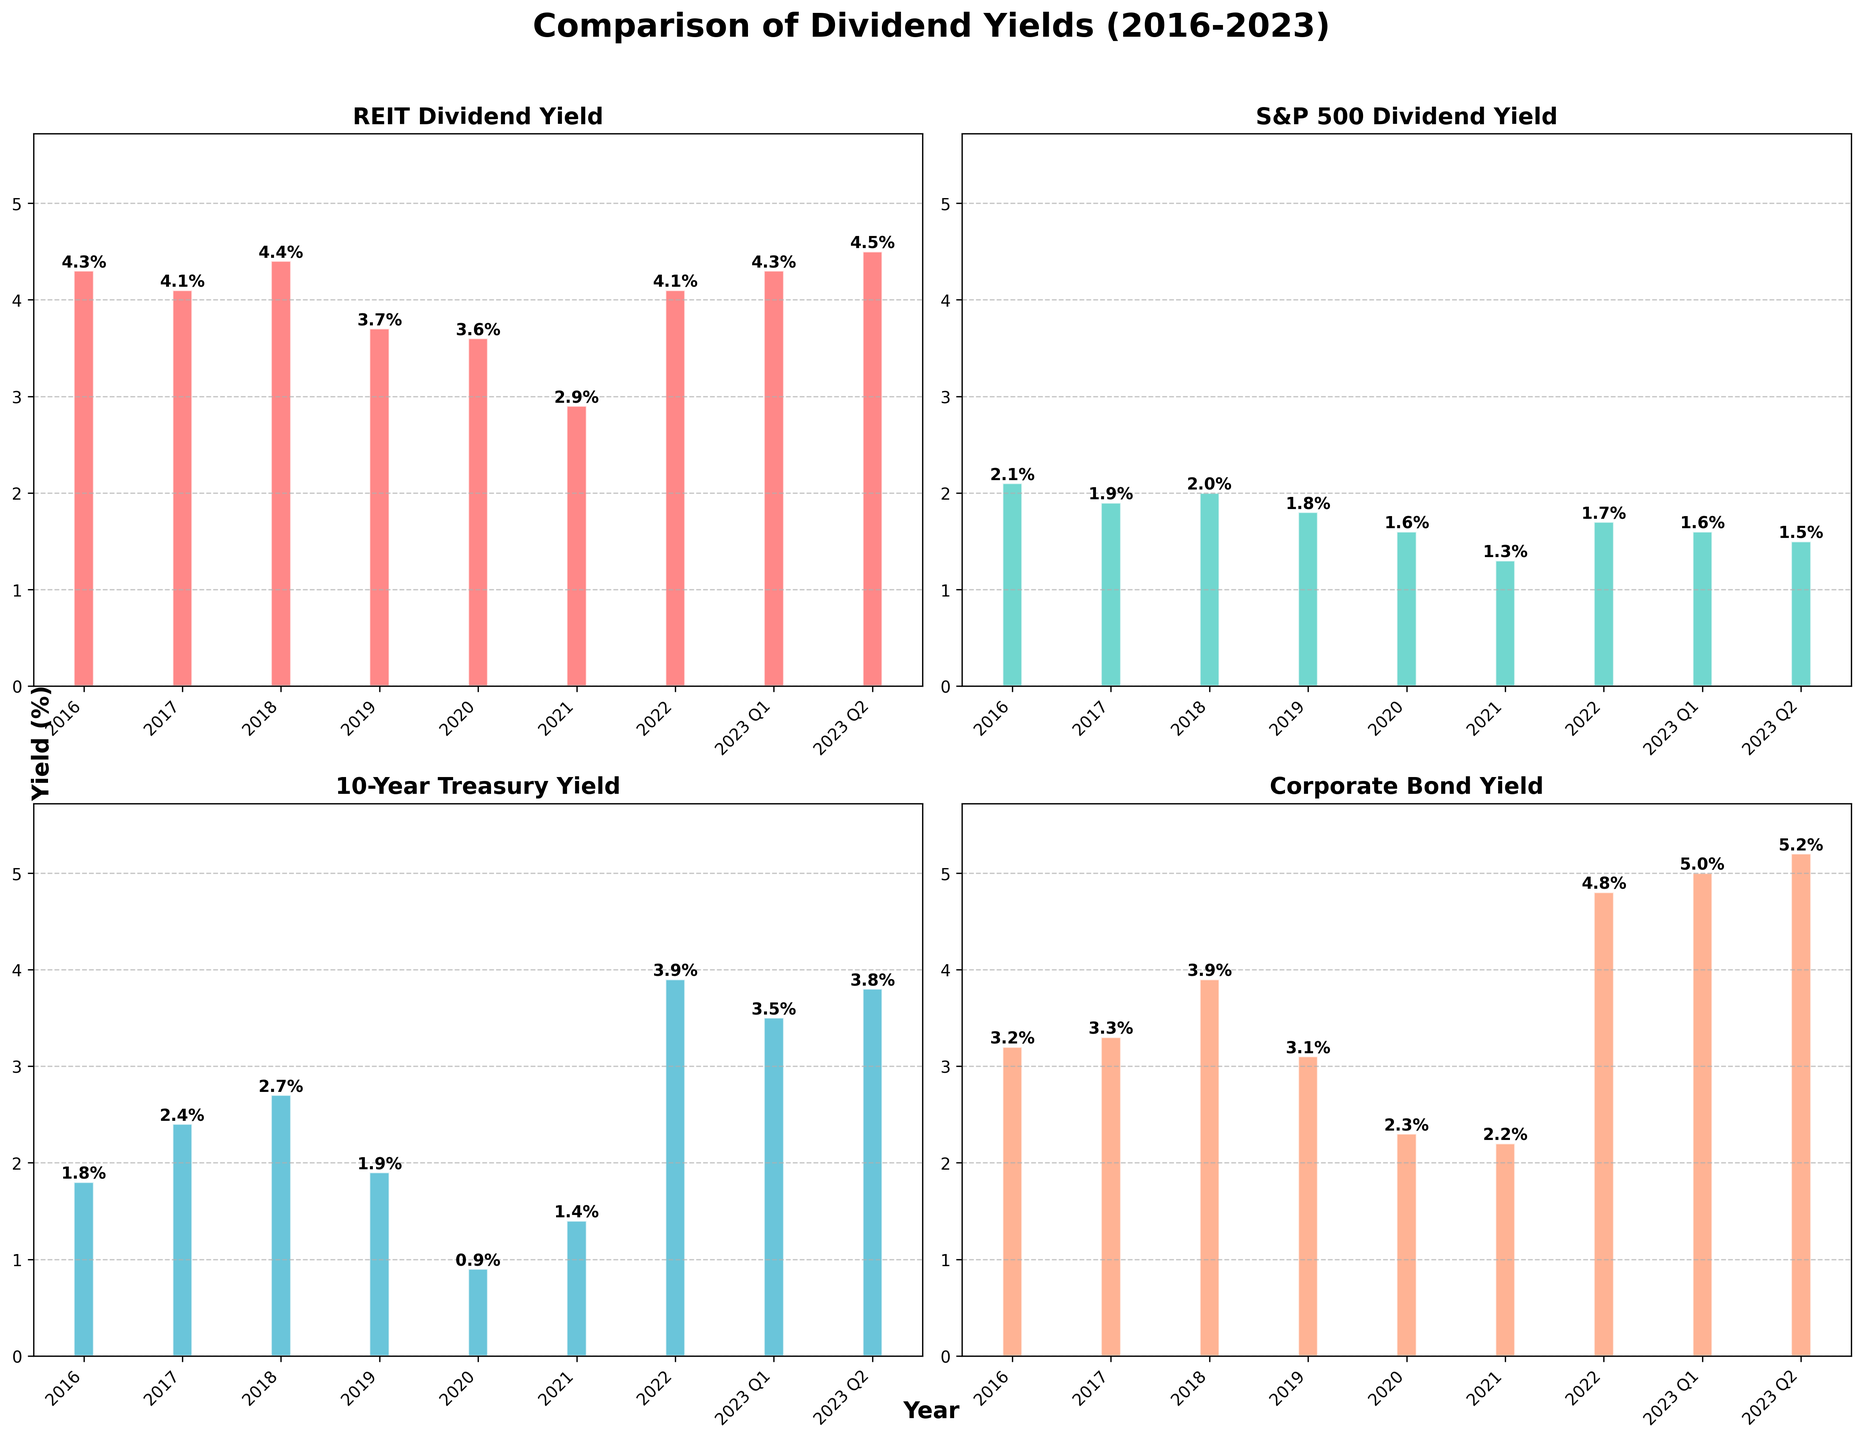Which investment type had the highest dividend yield in 2022? By looking at the bars for 2022 in each subplot, we see that the Corporate Bond Yield bar is the tallest.
Answer: Corporate Bond Yield How did the REIT dividend yield change from 2020 to 2021? To determine this, we look at the heights of the bars in the REIT Dividend Yield subplot for the years 2020 and 2021. The yield decreased from 3.6% in 2020 to 2.9% in 2021.
Answer: Decreased by 0.7% Is the S&P 500 dividend yield in 2023 Q2 higher or lower than in 2016? By comparing the bar heights for the years 2016 and 2023 Q2 in the S&P 500 Dividend Yield subplot, the yield decreased from 2.1% in 2016 to 1.5% in 2023 Q2.
Answer: Lower Which year had the lowest 10-Year Treasury Yield and what was that yield? By identifying the shortest bar in the 10-Year Treasury Yield subplot, we see that the year 2020 had the lowest yield at 0.9%.
Answer: 2020, 0.9% In which year(s) were the Corporate Bond yields higher than the REIT dividend yields? Compare the heights of the bars for Corporate Bond Yields and REIT Dividend Yields for each year. Corporate Bond Yields were higher in 2018, 2022, 2023 Q1, and 2023 Q2.
Answer: 2018, 2022, 2023 Q1, 2023 Q2 What is the average 10-Year Treasury Yield from 2016 to 2022? Sum the 10-Year Treasury Yields from 2016 to 2022 (1.8 + 2.4 + 2.7 + 1.9 + 0.9 + 1.4 + 3.9) and divide by the number of years (7). (1.8 + 2.4 + 2.7 + 1.9 + 0.9 + 1.4 + 3.9) / 7 = 2.14
Answer: 2.14% What is the difference in dividend yield between REITs and S&P 500 in 2023 Q1? The REIT dividend yield in 2023 Q1 is 4.3% and the S&P 500 dividend yield is 1.6%. Subtract the latter from the former: 4.3% - 1.6% = 2.7%
Answer: 2.7% In which year did the REIT dividend yield have its lowest value, and what was that yield? By spotting the shortest bar in the REIT Dividend Yield subplot, the year with the lowest yield was 2021, at 2.9%.
Answer: 2021, 2.9% Based on the visual information, did the Corporate Bond Yield ever fall below the REIT Dividend Yield during the period 2016-2023? Examine the bars for Corporate Bond Yield and REIT Dividend Yield; the Corporate Bond Yield was always below or roughly equal to the REIT Dividend Yield, except for 2018, 2022, 2023 Q1, and 2023 Q2.
Answer: Yes, except for 2018, 2022, 2023 Q1, 2023 Q2 